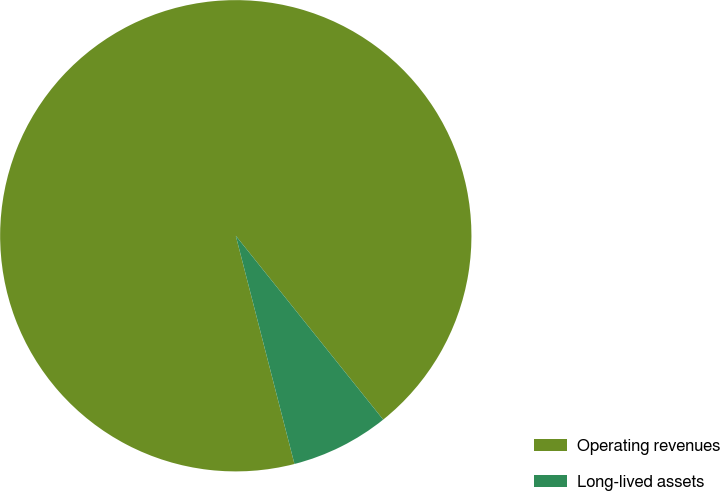<chart> <loc_0><loc_0><loc_500><loc_500><pie_chart><fcel>Operating revenues<fcel>Long-lived assets<nl><fcel>93.25%<fcel>6.75%<nl></chart> 